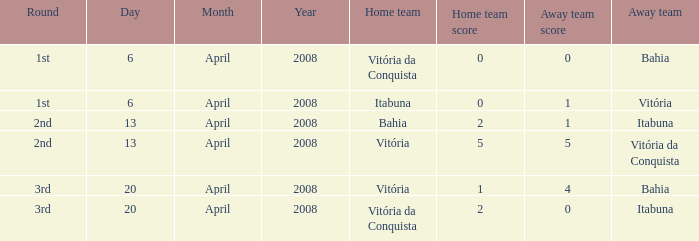Who was the host team on april 13, 2008 when itabuna was the visiting team? Bahia. Parse the full table. {'header': ['Round', 'Day', 'Month', 'Year', 'Home team', 'Home team score', 'Away team score', 'Away team'], 'rows': [['1st', '6', 'April', '2008', 'Vitória da Conquista', '0', '0', 'Bahia'], ['1st', '6', 'April', '2008', 'Itabuna', '0', '1', 'Vitória'], ['2nd', '13', 'April', '2008', 'Bahia', '2', '1', 'Itabuna'], ['2nd', '13', 'April', '2008', 'Vitória', '5', '5', 'Vitória da Conquista'], ['3rd', '20', 'April', '2008', 'Vitória', '1', '4', 'Bahia'], ['3rd', '20', 'April', '2008', 'Vitória da Conquista', '2', '0', 'Itabuna']]} 